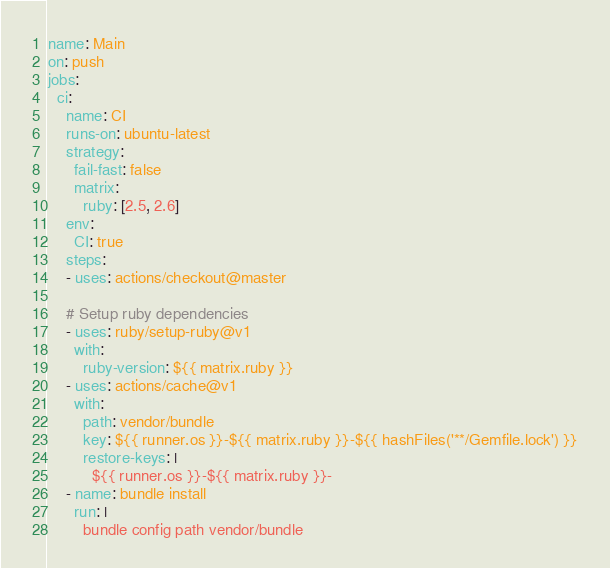Convert code to text. <code><loc_0><loc_0><loc_500><loc_500><_YAML_>name: Main
on: push
jobs:
  ci:
    name: CI
    runs-on: ubuntu-latest
    strategy:
      fail-fast: false
      matrix:
        ruby: [2.5, 2.6]
    env: 
      CI: true
    steps:
    - uses: actions/checkout@master

    # Setup ruby dependencies
    - uses: ruby/setup-ruby@v1
      with:
        ruby-version: ${{ matrix.ruby }}
    - uses: actions/cache@v1
      with:
        path: vendor/bundle
        key: ${{ runner.os }}-${{ matrix.ruby }}-${{ hashFiles('**/Gemfile.lock') }}
        restore-keys: |
          ${{ runner.os }}-${{ matrix.ruby }}-
    - name: bundle install
      run: |
        bundle config path vendor/bundle</code> 